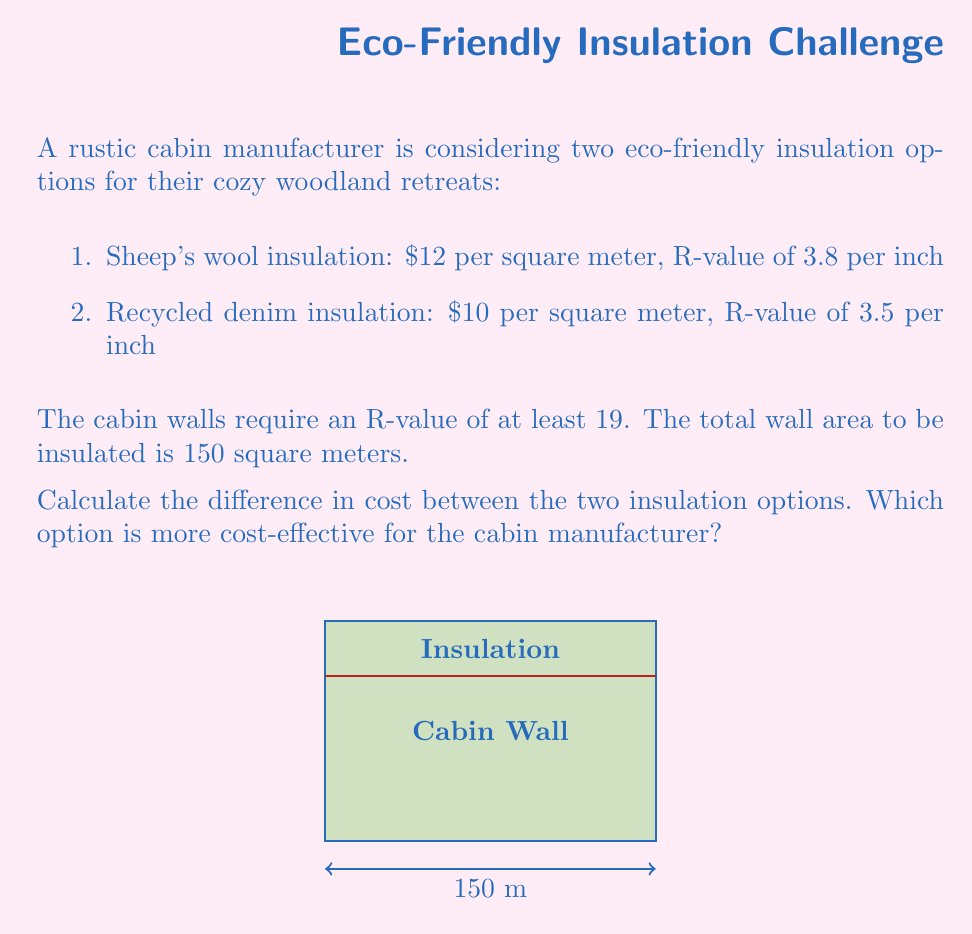Provide a solution to this math problem. Let's approach this step-by-step:

1) First, we need to determine the thickness of insulation required for each option:

   For sheep's wool: $\frac{19}{3.8} = 5$ inches
   For recycled denim: $\frac{19}{3.5} \approx 5.43$ inches

2) Now, let's calculate the cost for each option:

   Sheep's wool: $150 \text{ m}^2 \times $12/\text{m}^2 = $1800
   Recycled denim: $150 \text{ m}^2 \times $10/\text{m}^2 = $1500

3) To find the difference in cost:

   $1800 - $1500 = $300

4) To determine which is more cost-effective, we compare the costs:

   The recycled denim option costs $300 less than the sheep's wool option.

Therefore, the recycled denim insulation is more cost-effective for the cabin manufacturer.
Answer: $300 difference; Recycled denim is more cost-effective. 